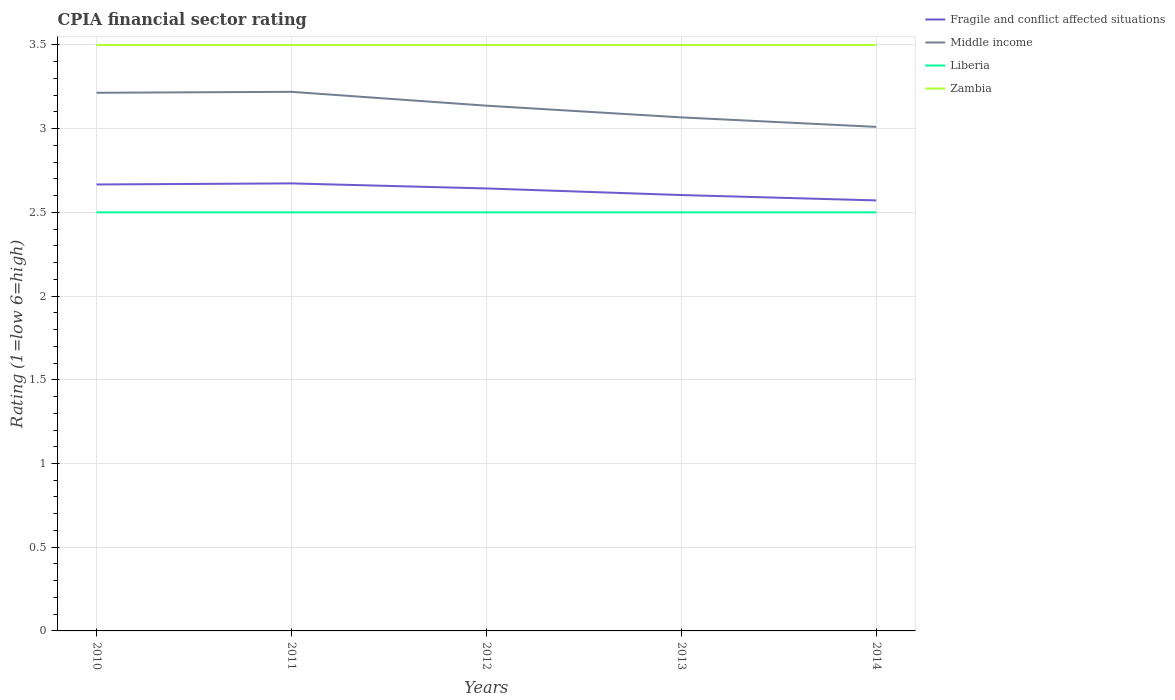How many different coloured lines are there?
Offer a terse response. 4. Does the line corresponding to Middle income intersect with the line corresponding to Zambia?
Keep it short and to the point. No. Is the number of lines equal to the number of legend labels?
Make the answer very short. Yes. Across all years, what is the maximum CPIA rating in Fragile and conflict affected situations?
Provide a succinct answer. 2.57. In which year was the CPIA rating in Fragile and conflict affected situations maximum?
Your answer should be compact. 2014. What is the total CPIA rating in Middle income in the graph?
Ensure brevity in your answer.  0.13. How many years are there in the graph?
Keep it short and to the point. 5. Are the values on the major ticks of Y-axis written in scientific E-notation?
Keep it short and to the point. No. Does the graph contain grids?
Give a very brief answer. Yes. How many legend labels are there?
Offer a terse response. 4. What is the title of the graph?
Provide a succinct answer. CPIA financial sector rating. What is the Rating (1=low 6=high) of Fragile and conflict affected situations in 2010?
Ensure brevity in your answer.  2.67. What is the Rating (1=low 6=high) of Middle income in 2010?
Offer a very short reply. 3.21. What is the Rating (1=low 6=high) of Liberia in 2010?
Your answer should be compact. 2.5. What is the Rating (1=low 6=high) of Fragile and conflict affected situations in 2011?
Keep it short and to the point. 2.67. What is the Rating (1=low 6=high) in Middle income in 2011?
Your answer should be very brief. 3.22. What is the Rating (1=low 6=high) of Zambia in 2011?
Keep it short and to the point. 3.5. What is the Rating (1=low 6=high) of Fragile and conflict affected situations in 2012?
Provide a succinct answer. 2.64. What is the Rating (1=low 6=high) of Middle income in 2012?
Your answer should be compact. 3.14. What is the Rating (1=low 6=high) in Fragile and conflict affected situations in 2013?
Keep it short and to the point. 2.6. What is the Rating (1=low 6=high) in Middle income in 2013?
Your answer should be very brief. 3.07. What is the Rating (1=low 6=high) in Zambia in 2013?
Your answer should be very brief. 3.5. What is the Rating (1=low 6=high) of Fragile and conflict affected situations in 2014?
Provide a succinct answer. 2.57. What is the Rating (1=low 6=high) of Middle income in 2014?
Keep it short and to the point. 3.01. Across all years, what is the maximum Rating (1=low 6=high) of Fragile and conflict affected situations?
Your response must be concise. 2.67. Across all years, what is the maximum Rating (1=low 6=high) of Middle income?
Make the answer very short. 3.22. Across all years, what is the maximum Rating (1=low 6=high) in Liberia?
Keep it short and to the point. 2.5. Across all years, what is the minimum Rating (1=low 6=high) of Fragile and conflict affected situations?
Your answer should be very brief. 2.57. Across all years, what is the minimum Rating (1=low 6=high) of Middle income?
Your response must be concise. 3.01. Across all years, what is the minimum Rating (1=low 6=high) of Liberia?
Your answer should be very brief. 2.5. Across all years, what is the minimum Rating (1=low 6=high) in Zambia?
Your answer should be compact. 3.5. What is the total Rating (1=low 6=high) of Fragile and conflict affected situations in the graph?
Make the answer very short. 13.16. What is the total Rating (1=low 6=high) of Middle income in the graph?
Make the answer very short. 15.65. What is the total Rating (1=low 6=high) in Liberia in the graph?
Provide a succinct answer. 12.5. What is the total Rating (1=low 6=high) in Zambia in the graph?
Provide a short and direct response. 17.5. What is the difference between the Rating (1=low 6=high) in Fragile and conflict affected situations in 2010 and that in 2011?
Keep it short and to the point. -0.01. What is the difference between the Rating (1=low 6=high) in Middle income in 2010 and that in 2011?
Your response must be concise. -0.01. What is the difference between the Rating (1=low 6=high) in Liberia in 2010 and that in 2011?
Offer a very short reply. 0. What is the difference between the Rating (1=low 6=high) of Fragile and conflict affected situations in 2010 and that in 2012?
Your answer should be very brief. 0.02. What is the difference between the Rating (1=low 6=high) of Middle income in 2010 and that in 2012?
Your response must be concise. 0.08. What is the difference between the Rating (1=low 6=high) of Liberia in 2010 and that in 2012?
Keep it short and to the point. 0. What is the difference between the Rating (1=low 6=high) in Zambia in 2010 and that in 2012?
Give a very brief answer. 0. What is the difference between the Rating (1=low 6=high) of Fragile and conflict affected situations in 2010 and that in 2013?
Give a very brief answer. 0.06. What is the difference between the Rating (1=low 6=high) of Middle income in 2010 and that in 2013?
Provide a short and direct response. 0.15. What is the difference between the Rating (1=low 6=high) of Fragile and conflict affected situations in 2010 and that in 2014?
Provide a short and direct response. 0.1. What is the difference between the Rating (1=low 6=high) of Middle income in 2010 and that in 2014?
Your response must be concise. 0.2. What is the difference between the Rating (1=low 6=high) in Fragile and conflict affected situations in 2011 and that in 2012?
Give a very brief answer. 0.03. What is the difference between the Rating (1=low 6=high) of Middle income in 2011 and that in 2012?
Offer a terse response. 0.08. What is the difference between the Rating (1=low 6=high) of Fragile and conflict affected situations in 2011 and that in 2013?
Offer a very short reply. 0.07. What is the difference between the Rating (1=low 6=high) of Middle income in 2011 and that in 2013?
Your response must be concise. 0.15. What is the difference between the Rating (1=low 6=high) in Zambia in 2011 and that in 2013?
Keep it short and to the point. 0. What is the difference between the Rating (1=low 6=high) in Fragile and conflict affected situations in 2011 and that in 2014?
Provide a short and direct response. 0.1. What is the difference between the Rating (1=low 6=high) in Middle income in 2011 and that in 2014?
Provide a succinct answer. 0.21. What is the difference between the Rating (1=low 6=high) in Liberia in 2011 and that in 2014?
Offer a terse response. 0. What is the difference between the Rating (1=low 6=high) in Zambia in 2011 and that in 2014?
Ensure brevity in your answer.  0. What is the difference between the Rating (1=low 6=high) of Fragile and conflict affected situations in 2012 and that in 2013?
Ensure brevity in your answer.  0.04. What is the difference between the Rating (1=low 6=high) in Middle income in 2012 and that in 2013?
Your answer should be very brief. 0.07. What is the difference between the Rating (1=low 6=high) of Liberia in 2012 and that in 2013?
Provide a succinct answer. 0. What is the difference between the Rating (1=low 6=high) of Zambia in 2012 and that in 2013?
Give a very brief answer. 0. What is the difference between the Rating (1=low 6=high) of Fragile and conflict affected situations in 2012 and that in 2014?
Offer a very short reply. 0.07. What is the difference between the Rating (1=low 6=high) in Middle income in 2012 and that in 2014?
Provide a short and direct response. 0.13. What is the difference between the Rating (1=low 6=high) of Zambia in 2012 and that in 2014?
Your answer should be very brief. 0. What is the difference between the Rating (1=low 6=high) of Fragile and conflict affected situations in 2013 and that in 2014?
Ensure brevity in your answer.  0.03. What is the difference between the Rating (1=low 6=high) in Middle income in 2013 and that in 2014?
Keep it short and to the point. 0.06. What is the difference between the Rating (1=low 6=high) in Liberia in 2013 and that in 2014?
Make the answer very short. 0. What is the difference between the Rating (1=low 6=high) of Fragile and conflict affected situations in 2010 and the Rating (1=low 6=high) of Middle income in 2011?
Keep it short and to the point. -0.55. What is the difference between the Rating (1=low 6=high) in Middle income in 2010 and the Rating (1=low 6=high) in Zambia in 2011?
Make the answer very short. -0.29. What is the difference between the Rating (1=low 6=high) in Fragile and conflict affected situations in 2010 and the Rating (1=low 6=high) in Middle income in 2012?
Your answer should be compact. -0.47. What is the difference between the Rating (1=low 6=high) in Middle income in 2010 and the Rating (1=low 6=high) in Zambia in 2012?
Provide a succinct answer. -0.29. What is the difference between the Rating (1=low 6=high) in Fragile and conflict affected situations in 2010 and the Rating (1=low 6=high) in Middle income in 2013?
Keep it short and to the point. -0.4. What is the difference between the Rating (1=low 6=high) in Fragile and conflict affected situations in 2010 and the Rating (1=low 6=high) in Liberia in 2013?
Your response must be concise. 0.17. What is the difference between the Rating (1=low 6=high) of Middle income in 2010 and the Rating (1=low 6=high) of Liberia in 2013?
Give a very brief answer. 0.71. What is the difference between the Rating (1=low 6=high) of Middle income in 2010 and the Rating (1=low 6=high) of Zambia in 2013?
Your response must be concise. -0.29. What is the difference between the Rating (1=low 6=high) in Fragile and conflict affected situations in 2010 and the Rating (1=low 6=high) in Middle income in 2014?
Provide a succinct answer. -0.34. What is the difference between the Rating (1=low 6=high) of Fragile and conflict affected situations in 2010 and the Rating (1=low 6=high) of Liberia in 2014?
Your answer should be very brief. 0.17. What is the difference between the Rating (1=low 6=high) of Fragile and conflict affected situations in 2010 and the Rating (1=low 6=high) of Zambia in 2014?
Ensure brevity in your answer.  -0.83. What is the difference between the Rating (1=low 6=high) in Middle income in 2010 and the Rating (1=low 6=high) in Liberia in 2014?
Keep it short and to the point. 0.71. What is the difference between the Rating (1=low 6=high) in Middle income in 2010 and the Rating (1=low 6=high) in Zambia in 2014?
Your answer should be compact. -0.29. What is the difference between the Rating (1=low 6=high) of Fragile and conflict affected situations in 2011 and the Rating (1=low 6=high) of Middle income in 2012?
Make the answer very short. -0.46. What is the difference between the Rating (1=low 6=high) of Fragile and conflict affected situations in 2011 and the Rating (1=low 6=high) of Liberia in 2012?
Make the answer very short. 0.17. What is the difference between the Rating (1=low 6=high) in Fragile and conflict affected situations in 2011 and the Rating (1=low 6=high) in Zambia in 2012?
Your response must be concise. -0.83. What is the difference between the Rating (1=low 6=high) of Middle income in 2011 and the Rating (1=low 6=high) of Liberia in 2012?
Ensure brevity in your answer.  0.72. What is the difference between the Rating (1=low 6=high) in Middle income in 2011 and the Rating (1=low 6=high) in Zambia in 2012?
Give a very brief answer. -0.28. What is the difference between the Rating (1=low 6=high) in Fragile and conflict affected situations in 2011 and the Rating (1=low 6=high) in Middle income in 2013?
Your response must be concise. -0.39. What is the difference between the Rating (1=low 6=high) in Fragile and conflict affected situations in 2011 and the Rating (1=low 6=high) in Liberia in 2013?
Make the answer very short. 0.17. What is the difference between the Rating (1=low 6=high) in Fragile and conflict affected situations in 2011 and the Rating (1=low 6=high) in Zambia in 2013?
Give a very brief answer. -0.83. What is the difference between the Rating (1=low 6=high) in Middle income in 2011 and the Rating (1=low 6=high) in Liberia in 2013?
Your answer should be very brief. 0.72. What is the difference between the Rating (1=low 6=high) of Middle income in 2011 and the Rating (1=low 6=high) of Zambia in 2013?
Make the answer very short. -0.28. What is the difference between the Rating (1=low 6=high) in Fragile and conflict affected situations in 2011 and the Rating (1=low 6=high) in Middle income in 2014?
Provide a short and direct response. -0.34. What is the difference between the Rating (1=low 6=high) of Fragile and conflict affected situations in 2011 and the Rating (1=low 6=high) of Liberia in 2014?
Provide a short and direct response. 0.17. What is the difference between the Rating (1=low 6=high) in Fragile and conflict affected situations in 2011 and the Rating (1=low 6=high) in Zambia in 2014?
Offer a very short reply. -0.83. What is the difference between the Rating (1=low 6=high) in Middle income in 2011 and the Rating (1=low 6=high) in Liberia in 2014?
Your answer should be compact. 0.72. What is the difference between the Rating (1=low 6=high) in Middle income in 2011 and the Rating (1=low 6=high) in Zambia in 2014?
Your answer should be compact. -0.28. What is the difference between the Rating (1=low 6=high) of Liberia in 2011 and the Rating (1=low 6=high) of Zambia in 2014?
Keep it short and to the point. -1. What is the difference between the Rating (1=low 6=high) in Fragile and conflict affected situations in 2012 and the Rating (1=low 6=high) in Middle income in 2013?
Your answer should be compact. -0.42. What is the difference between the Rating (1=low 6=high) in Fragile and conflict affected situations in 2012 and the Rating (1=low 6=high) in Liberia in 2013?
Give a very brief answer. 0.14. What is the difference between the Rating (1=low 6=high) in Fragile and conflict affected situations in 2012 and the Rating (1=low 6=high) in Zambia in 2013?
Your response must be concise. -0.86. What is the difference between the Rating (1=low 6=high) in Middle income in 2012 and the Rating (1=low 6=high) in Liberia in 2013?
Provide a short and direct response. 0.64. What is the difference between the Rating (1=low 6=high) in Middle income in 2012 and the Rating (1=low 6=high) in Zambia in 2013?
Offer a very short reply. -0.36. What is the difference between the Rating (1=low 6=high) of Liberia in 2012 and the Rating (1=low 6=high) of Zambia in 2013?
Offer a very short reply. -1. What is the difference between the Rating (1=low 6=high) of Fragile and conflict affected situations in 2012 and the Rating (1=low 6=high) of Middle income in 2014?
Provide a short and direct response. -0.37. What is the difference between the Rating (1=low 6=high) in Fragile and conflict affected situations in 2012 and the Rating (1=low 6=high) in Liberia in 2014?
Provide a short and direct response. 0.14. What is the difference between the Rating (1=low 6=high) of Fragile and conflict affected situations in 2012 and the Rating (1=low 6=high) of Zambia in 2014?
Your answer should be compact. -0.86. What is the difference between the Rating (1=low 6=high) of Middle income in 2012 and the Rating (1=low 6=high) of Liberia in 2014?
Your answer should be compact. 0.64. What is the difference between the Rating (1=low 6=high) in Middle income in 2012 and the Rating (1=low 6=high) in Zambia in 2014?
Provide a short and direct response. -0.36. What is the difference between the Rating (1=low 6=high) in Fragile and conflict affected situations in 2013 and the Rating (1=low 6=high) in Middle income in 2014?
Provide a succinct answer. -0.41. What is the difference between the Rating (1=low 6=high) in Fragile and conflict affected situations in 2013 and the Rating (1=low 6=high) in Liberia in 2014?
Your response must be concise. 0.1. What is the difference between the Rating (1=low 6=high) of Fragile and conflict affected situations in 2013 and the Rating (1=low 6=high) of Zambia in 2014?
Give a very brief answer. -0.9. What is the difference between the Rating (1=low 6=high) in Middle income in 2013 and the Rating (1=low 6=high) in Liberia in 2014?
Offer a terse response. 0.57. What is the difference between the Rating (1=low 6=high) of Middle income in 2013 and the Rating (1=low 6=high) of Zambia in 2014?
Provide a succinct answer. -0.43. What is the difference between the Rating (1=low 6=high) in Liberia in 2013 and the Rating (1=low 6=high) in Zambia in 2014?
Ensure brevity in your answer.  -1. What is the average Rating (1=low 6=high) in Fragile and conflict affected situations per year?
Offer a very short reply. 2.63. What is the average Rating (1=low 6=high) of Middle income per year?
Give a very brief answer. 3.13. What is the average Rating (1=low 6=high) in Zambia per year?
Your answer should be compact. 3.5. In the year 2010, what is the difference between the Rating (1=low 6=high) of Fragile and conflict affected situations and Rating (1=low 6=high) of Middle income?
Your answer should be very brief. -0.55. In the year 2010, what is the difference between the Rating (1=low 6=high) of Fragile and conflict affected situations and Rating (1=low 6=high) of Liberia?
Offer a very short reply. 0.17. In the year 2010, what is the difference between the Rating (1=low 6=high) of Middle income and Rating (1=low 6=high) of Zambia?
Give a very brief answer. -0.29. In the year 2011, what is the difference between the Rating (1=low 6=high) in Fragile and conflict affected situations and Rating (1=low 6=high) in Middle income?
Offer a terse response. -0.55. In the year 2011, what is the difference between the Rating (1=low 6=high) in Fragile and conflict affected situations and Rating (1=low 6=high) in Liberia?
Your response must be concise. 0.17. In the year 2011, what is the difference between the Rating (1=low 6=high) of Fragile and conflict affected situations and Rating (1=low 6=high) of Zambia?
Offer a terse response. -0.83. In the year 2011, what is the difference between the Rating (1=low 6=high) of Middle income and Rating (1=low 6=high) of Liberia?
Your answer should be very brief. 0.72. In the year 2011, what is the difference between the Rating (1=low 6=high) of Middle income and Rating (1=low 6=high) of Zambia?
Provide a short and direct response. -0.28. In the year 2012, what is the difference between the Rating (1=low 6=high) of Fragile and conflict affected situations and Rating (1=low 6=high) of Middle income?
Provide a succinct answer. -0.49. In the year 2012, what is the difference between the Rating (1=low 6=high) of Fragile and conflict affected situations and Rating (1=low 6=high) of Liberia?
Your answer should be compact. 0.14. In the year 2012, what is the difference between the Rating (1=low 6=high) in Fragile and conflict affected situations and Rating (1=low 6=high) in Zambia?
Give a very brief answer. -0.86. In the year 2012, what is the difference between the Rating (1=low 6=high) in Middle income and Rating (1=low 6=high) in Liberia?
Your answer should be very brief. 0.64. In the year 2012, what is the difference between the Rating (1=low 6=high) in Middle income and Rating (1=low 6=high) in Zambia?
Offer a terse response. -0.36. In the year 2013, what is the difference between the Rating (1=low 6=high) of Fragile and conflict affected situations and Rating (1=low 6=high) of Middle income?
Ensure brevity in your answer.  -0.46. In the year 2013, what is the difference between the Rating (1=low 6=high) in Fragile and conflict affected situations and Rating (1=low 6=high) in Liberia?
Ensure brevity in your answer.  0.1. In the year 2013, what is the difference between the Rating (1=low 6=high) of Fragile and conflict affected situations and Rating (1=low 6=high) of Zambia?
Offer a very short reply. -0.9. In the year 2013, what is the difference between the Rating (1=low 6=high) of Middle income and Rating (1=low 6=high) of Liberia?
Your answer should be compact. 0.57. In the year 2013, what is the difference between the Rating (1=low 6=high) in Middle income and Rating (1=low 6=high) in Zambia?
Your response must be concise. -0.43. In the year 2013, what is the difference between the Rating (1=low 6=high) of Liberia and Rating (1=low 6=high) of Zambia?
Ensure brevity in your answer.  -1. In the year 2014, what is the difference between the Rating (1=low 6=high) in Fragile and conflict affected situations and Rating (1=low 6=high) in Middle income?
Offer a very short reply. -0.44. In the year 2014, what is the difference between the Rating (1=low 6=high) of Fragile and conflict affected situations and Rating (1=low 6=high) of Liberia?
Make the answer very short. 0.07. In the year 2014, what is the difference between the Rating (1=low 6=high) in Fragile and conflict affected situations and Rating (1=low 6=high) in Zambia?
Offer a very short reply. -0.93. In the year 2014, what is the difference between the Rating (1=low 6=high) in Middle income and Rating (1=low 6=high) in Liberia?
Your answer should be compact. 0.51. In the year 2014, what is the difference between the Rating (1=low 6=high) of Middle income and Rating (1=low 6=high) of Zambia?
Make the answer very short. -0.49. In the year 2014, what is the difference between the Rating (1=low 6=high) in Liberia and Rating (1=low 6=high) in Zambia?
Make the answer very short. -1. What is the ratio of the Rating (1=low 6=high) in Zambia in 2010 to that in 2011?
Keep it short and to the point. 1. What is the ratio of the Rating (1=low 6=high) of Fragile and conflict affected situations in 2010 to that in 2012?
Your answer should be very brief. 1.01. What is the ratio of the Rating (1=low 6=high) in Middle income in 2010 to that in 2012?
Offer a very short reply. 1.02. What is the ratio of the Rating (1=low 6=high) in Zambia in 2010 to that in 2012?
Give a very brief answer. 1. What is the ratio of the Rating (1=low 6=high) in Fragile and conflict affected situations in 2010 to that in 2013?
Offer a very short reply. 1.02. What is the ratio of the Rating (1=low 6=high) of Middle income in 2010 to that in 2013?
Ensure brevity in your answer.  1.05. What is the ratio of the Rating (1=low 6=high) in Fragile and conflict affected situations in 2010 to that in 2014?
Provide a short and direct response. 1.04. What is the ratio of the Rating (1=low 6=high) of Middle income in 2010 to that in 2014?
Offer a very short reply. 1.07. What is the ratio of the Rating (1=low 6=high) in Liberia in 2010 to that in 2014?
Your answer should be very brief. 1. What is the ratio of the Rating (1=low 6=high) of Zambia in 2010 to that in 2014?
Your answer should be compact. 1. What is the ratio of the Rating (1=low 6=high) in Fragile and conflict affected situations in 2011 to that in 2012?
Your answer should be compact. 1.01. What is the ratio of the Rating (1=low 6=high) of Middle income in 2011 to that in 2012?
Give a very brief answer. 1.03. What is the ratio of the Rating (1=low 6=high) in Zambia in 2011 to that in 2012?
Your response must be concise. 1. What is the ratio of the Rating (1=low 6=high) of Fragile and conflict affected situations in 2011 to that in 2013?
Your answer should be compact. 1.03. What is the ratio of the Rating (1=low 6=high) in Middle income in 2011 to that in 2013?
Ensure brevity in your answer.  1.05. What is the ratio of the Rating (1=low 6=high) of Liberia in 2011 to that in 2013?
Offer a terse response. 1. What is the ratio of the Rating (1=low 6=high) in Zambia in 2011 to that in 2013?
Give a very brief answer. 1. What is the ratio of the Rating (1=low 6=high) of Fragile and conflict affected situations in 2011 to that in 2014?
Offer a very short reply. 1.04. What is the ratio of the Rating (1=low 6=high) in Middle income in 2011 to that in 2014?
Provide a succinct answer. 1.07. What is the ratio of the Rating (1=low 6=high) of Zambia in 2011 to that in 2014?
Your answer should be compact. 1. What is the ratio of the Rating (1=low 6=high) of Fragile and conflict affected situations in 2012 to that in 2013?
Your answer should be very brief. 1.02. What is the ratio of the Rating (1=low 6=high) of Middle income in 2012 to that in 2013?
Offer a very short reply. 1.02. What is the ratio of the Rating (1=low 6=high) in Liberia in 2012 to that in 2013?
Your answer should be compact. 1. What is the ratio of the Rating (1=low 6=high) in Fragile and conflict affected situations in 2012 to that in 2014?
Your answer should be compact. 1.03. What is the ratio of the Rating (1=low 6=high) of Middle income in 2012 to that in 2014?
Offer a terse response. 1.04. What is the ratio of the Rating (1=low 6=high) in Fragile and conflict affected situations in 2013 to that in 2014?
Ensure brevity in your answer.  1.01. What is the ratio of the Rating (1=low 6=high) of Middle income in 2013 to that in 2014?
Provide a succinct answer. 1.02. What is the ratio of the Rating (1=low 6=high) of Zambia in 2013 to that in 2014?
Your answer should be compact. 1. What is the difference between the highest and the second highest Rating (1=low 6=high) in Fragile and conflict affected situations?
Your answer should be compact. 0.01. What is the difference between the highest and the second highest Rating (1=low 6=high) of Middle income?
Make the answer very short. 0.01. What is the difference between the highest and the second highest Rating (1=low 6=high) in Zambia?
Offer a terse response. 0. What is the difference between the highest and the lowest Rating (1=low 6=high) in Fragile and conflict affected situations?
Keep it short and to the point. 0.1. What is the difference between the highest and the lowest Rating (1=low 6=high) of Middle income?
Make the answer very short. 0.21. What is the difference between the highest and the lowest Rating (1=low 6=high) in Liberia?
Your answer should be very brief. 0. What is the difference between the highest and the lowest Rating (1=low 6=high) of Zambia?
Your answer should be very brief. 0. 